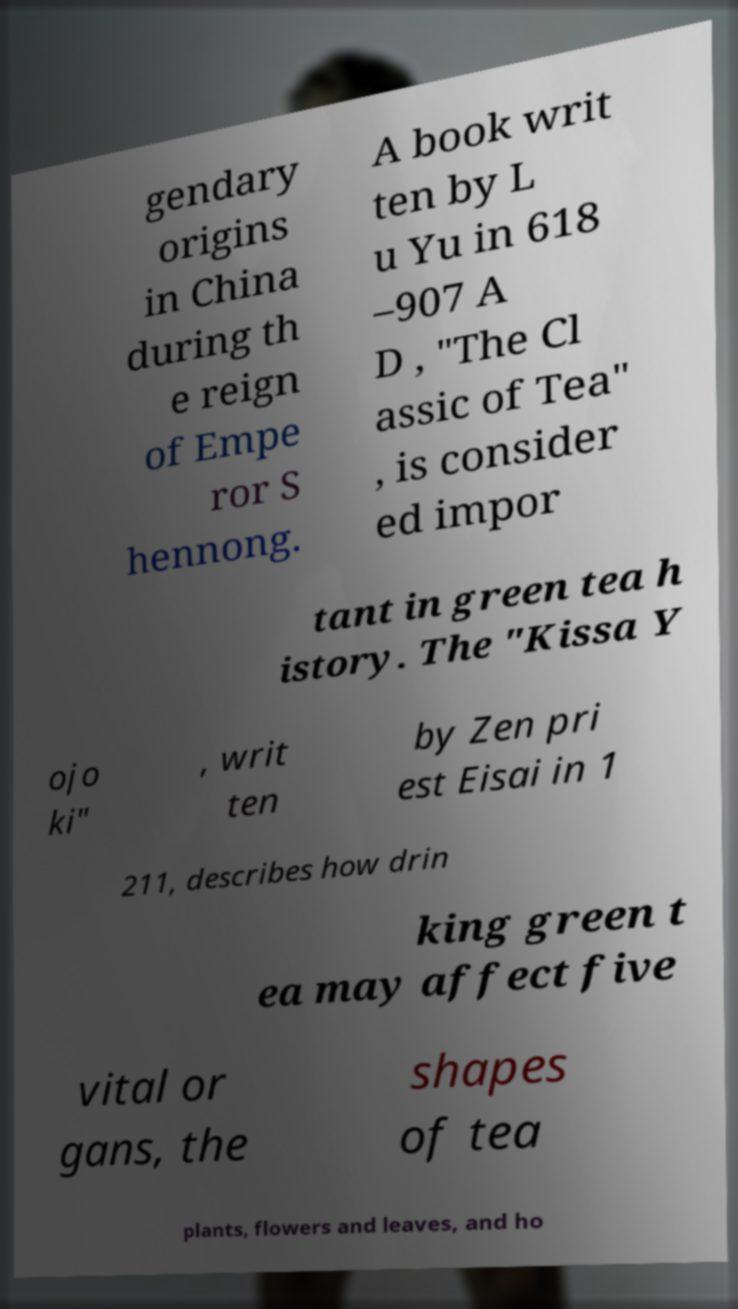Could you assist in decoding the text presented in this image and type it out clearly? gendary origins in China during th e reign of Empe ror S hennong. A book writ ten by L u Yu in 618 –907 A D , "The Cl assic of Tea" , is consider ed impor tant in green tea h istory. The "Kissa Y ojo ki" , writ ten by Zen pri est Eisai in 1 211, describes how drin king green t ea may affect five vital or gans, the shapes of tea plants, flowers and leaves, and ho 